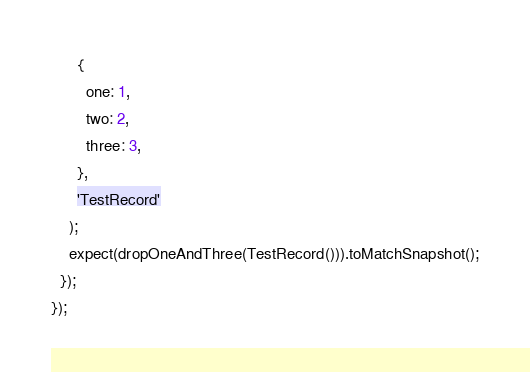Convert code to text. <code><loc_0><loc_0><loc_500><loc_500><_JavaScript_>      {
        one: 1,
        two: 2,
        three: 3,
      },
      'TestRecord'
    );
    expect(dropOneAndThree(TestRecord())).toMatchSnapshot();
  });
});
</code> 